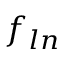Convert formula to latex. <formula><loc_0><loc_0><loc_500><loc_500>f _ { \ln }</formula> 